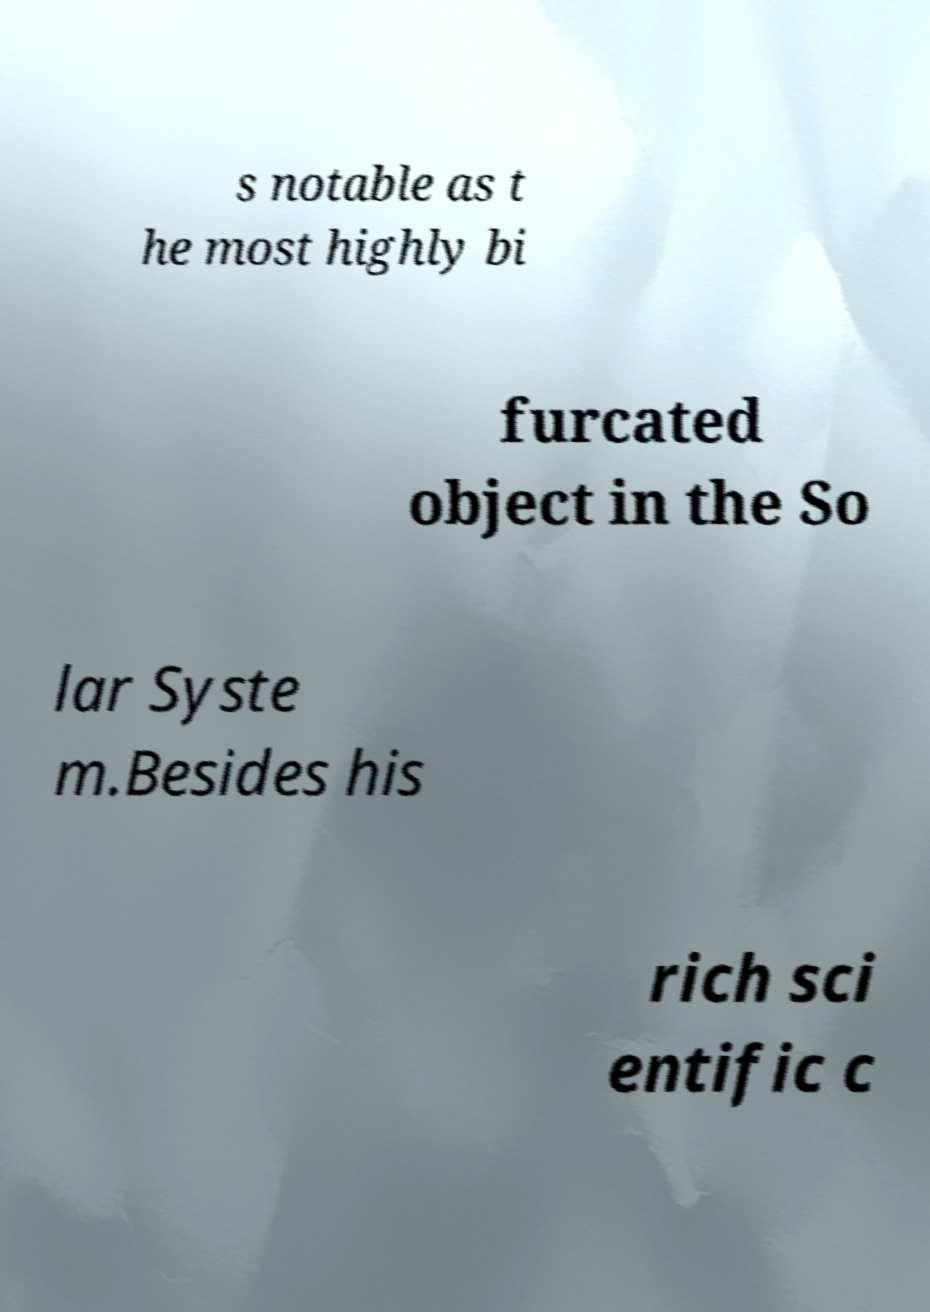What messages or text are displayed in this image? I need them in a readable, typed format. s notable as t he most highly bi furcated object in the So lar Syste m.Besides his rich sci entific c 